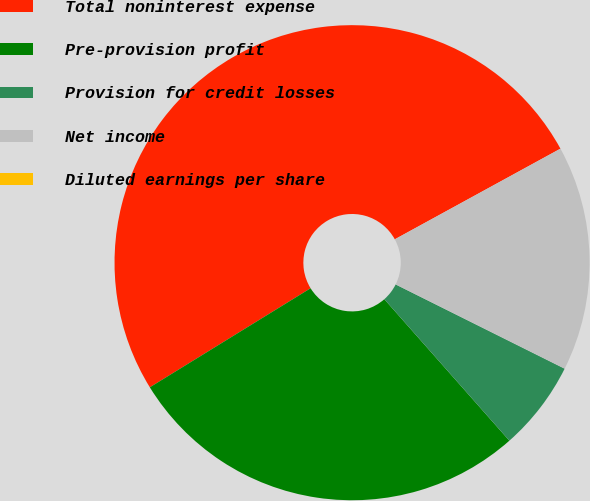<chart> <loc_0><loc_0><loc_500><loc_500><pie_chart><fcel>Total noninterest expense<fcel>Pre-provision profit<fcel>Provision for credit losses<fcel>Net income<fcel>Diluted earnings per share<nl><fcel>50.82%<fcel>27.73%<fcel>6.12%<fcel>15.33%<fcel>0.0%<nl></chart> 